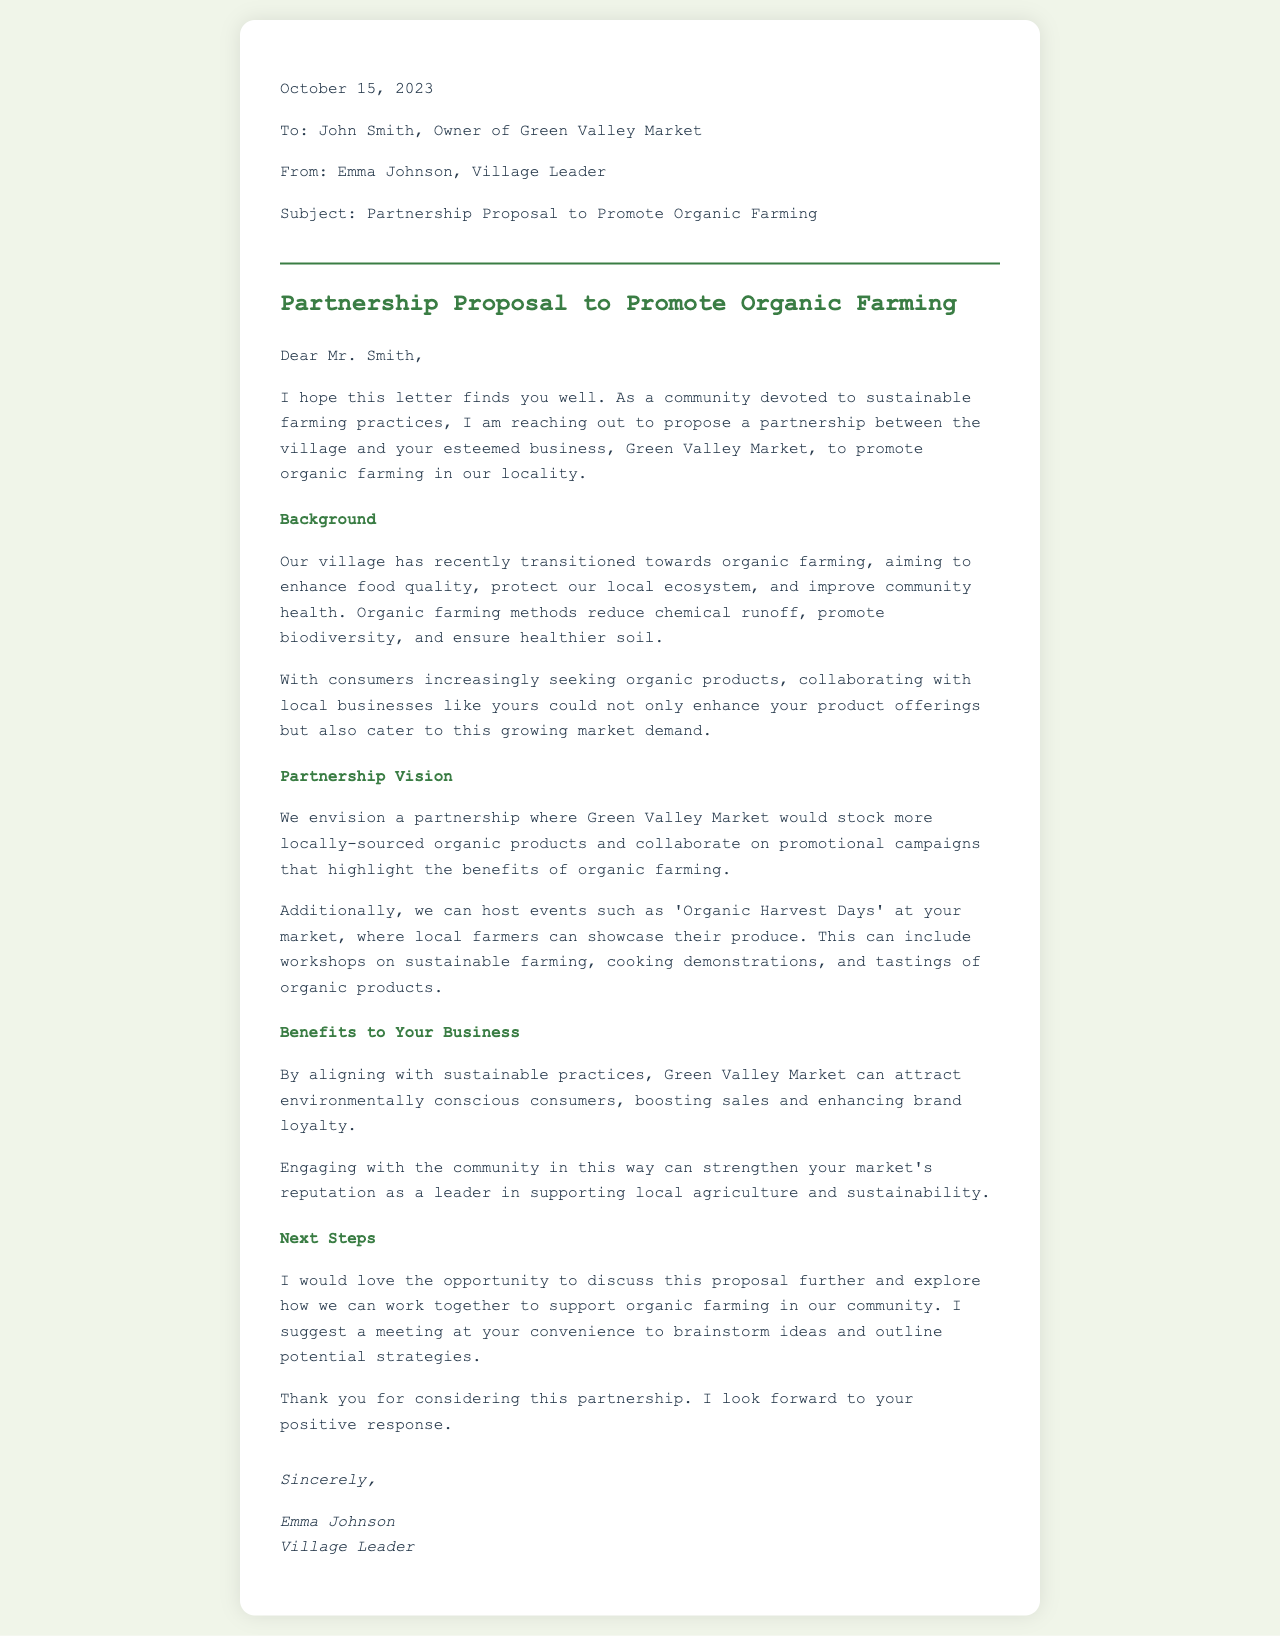What is the date of the letter? The date of the letter is mentioned at the beginning of the document.
Answer: October 15, 2023 Who is the owner of Green Valley Market? The owner of Green Valley Market is specified in the opening address of the letter.
Answer: John Smith What is the main subject of the letter? The subject line of the letter clearly states the purpose of the proposal.
Answer: Partnership Proposal to Promote Organic Farming What is the vision for the partnership? The section titled "Partnership Vision" describes the envisioned collaboration with the business.
Answer: Stock more locally-sourced organic products What benefits does the proposal highlight for Green Valley Market? The letter outlines the advantages of the partnership in the section titled "Benefits to Your Business."
Answer: Attract environmentally conscious consumers What types of events are suggested in the proposal? The document lists specific activities that could be part of the partnership as mentioned under "Partnership Vision."
Answer: Organic Harvest Days What is the closing statement of the letter? The final section of the letter concludes with a polite expression regarding expectations of a response.
Answer: I look forward to your positive response What does Emma Johnson hold in the village? The signature section indicates the role of the writer in the community.
Answer: Village Leader 